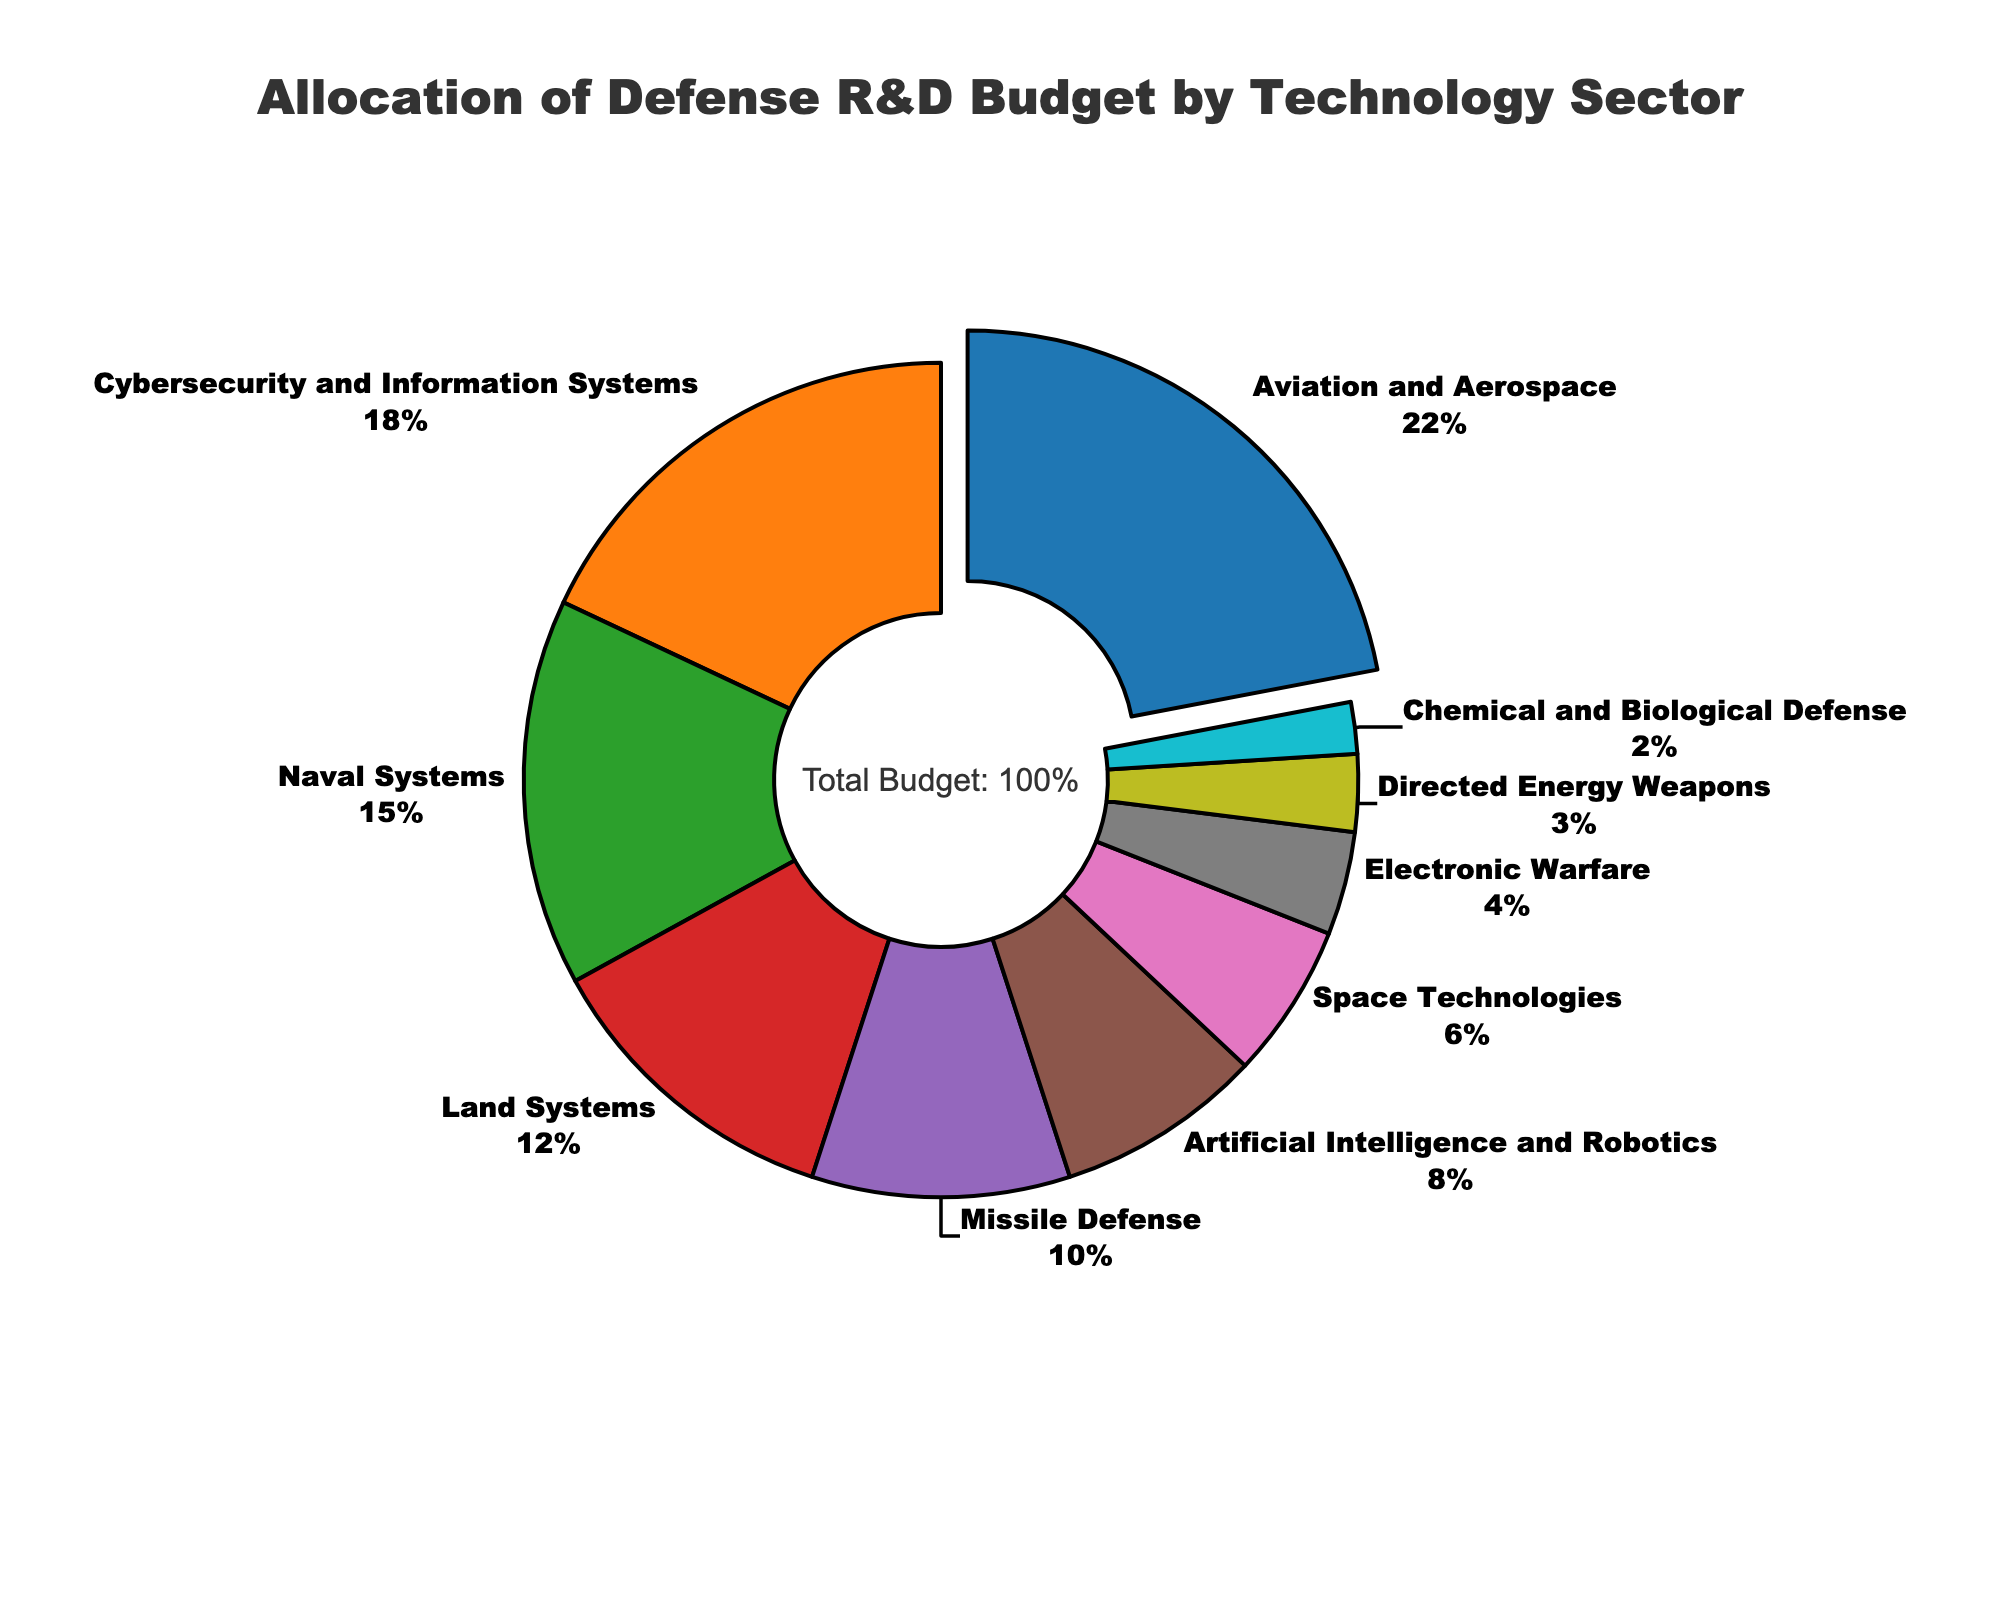What's the total percentage allocation for Cybersecurity and Information Systems and Artificial Intelligence and Robotics? Add the percentage allocation for Cybersecurity and Information Systems (18%) and Artificial Intelligence and Robotics (8%). 18 + 8 = 26
Answer: 26% Which technology sector receives the highest budget allocation? Identify the sector with the highest percentage from the pie chart. Aviation and Aerospace has the highest allocation at 22%
Answer: Aviation and Aerospace Is the budget allocation for Naval Systems greater than that for Space Technologies? Compare the percentages of Naval Systems (15%) and Space Technologies (6%). 15% is greater than 6%
Answer: Yes What's the budget allocation percentage for Land Systems plus Missile Defense? Add the percentage allocation for Land Systems (12%) and Missile Defense (10%). 12 + 10 = 22
Answer: 22% Which sector has the smallest budget allocation, and what is its percentage? Identify the sector with the smallest percentage from the pie chart. Chemical and Biological Defense has the smallest allocation at 2%
Answer: Chemical and Biological Defense, 2% How much percent higher is the allocation for Aviation and Aerospace compared to Space Technologies? Subtract the percentage of Space Technologies (6%) from the percentage of Aviation and Aerospace (22%). 22 - 6 = 16
Answer: 16% Which sectors have a budget allocation that is less than 10%? Identify sectors with less than 10% allocation: Artificial Intelligence and Robotics (8%), Space Technologies (6%), Electronic Warfare (4%), Directed Energy Weapons (3%), and Chemical and Biological Defense (2%)
Answer: Artificial Intelligence and Robotics, Space Technologies, Electronic Warfare, Directed Energy Weapons, Chemical and Biological Defense What percentage of the budget is allocated to sectors involved directly in electronic and information warfare (i.e., Cybersecurity and Information Systems, Electronic Warfare)? Add the percentage allocations for Cybersecurity and Information Systems (18%) and Electronic Warfare (4%). 18 + 4 = 22
Answer: 22% How much more of the budget is allocated to Land Systems compared to Directed Energy Weapons? Subtract the percentage of Directed Energy Weapons (3%) from the percentage of Land Systems (12%). 12 - 3 = 9
Answer: 9% 